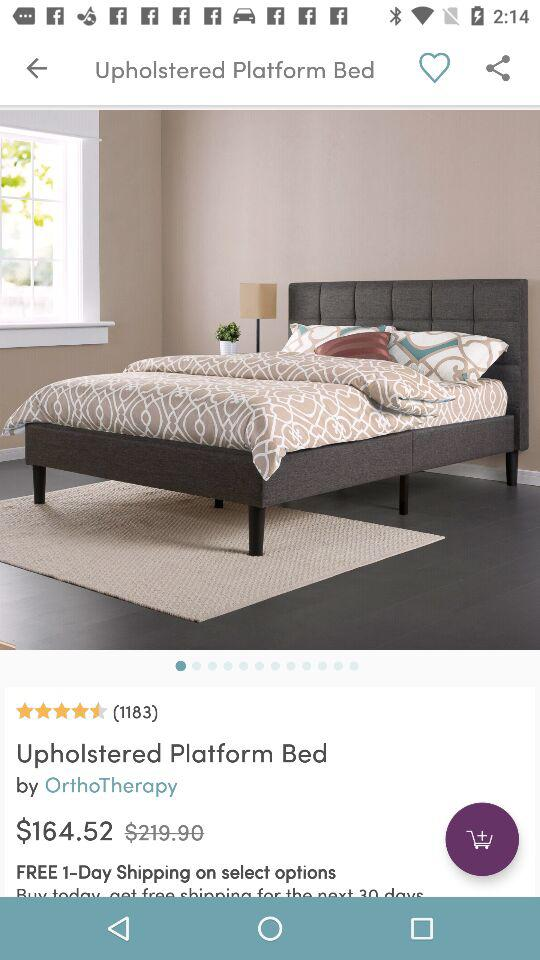How many days of free shipping are available on the selected options? There is 1 day of free shipping available on the selected options. 